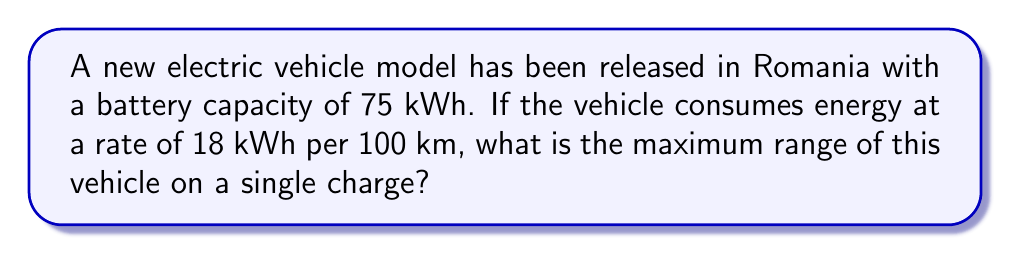Show me your answer to this math problem. To solve this problem, we need to follow these steps:

1. Understand the given information:
   - Battery capacity: 75 kWh
   - Energy consumption: 18 kWh per 100 km

2. Set up the equation:
   Let $x$ be the maximum range in km.
   $$\frac{75 \text{ kWh}}{x \text{ km}} = \frac{18 \text{ kWh}}{100 \text{ km}}$$

3. Cross multiply:
   $$75 \cdot 100 = 18x$$

4. Solve for $x$:
   $$7500 = 18x$$
   $$x = \frac{7500}{18}$$

5. Calculate the result:
   $$x = 416.67 \text{ km}$$

6. Round to a reasonable precision:
   The maximum range is approximately 417 km.
Answer: 417 km 